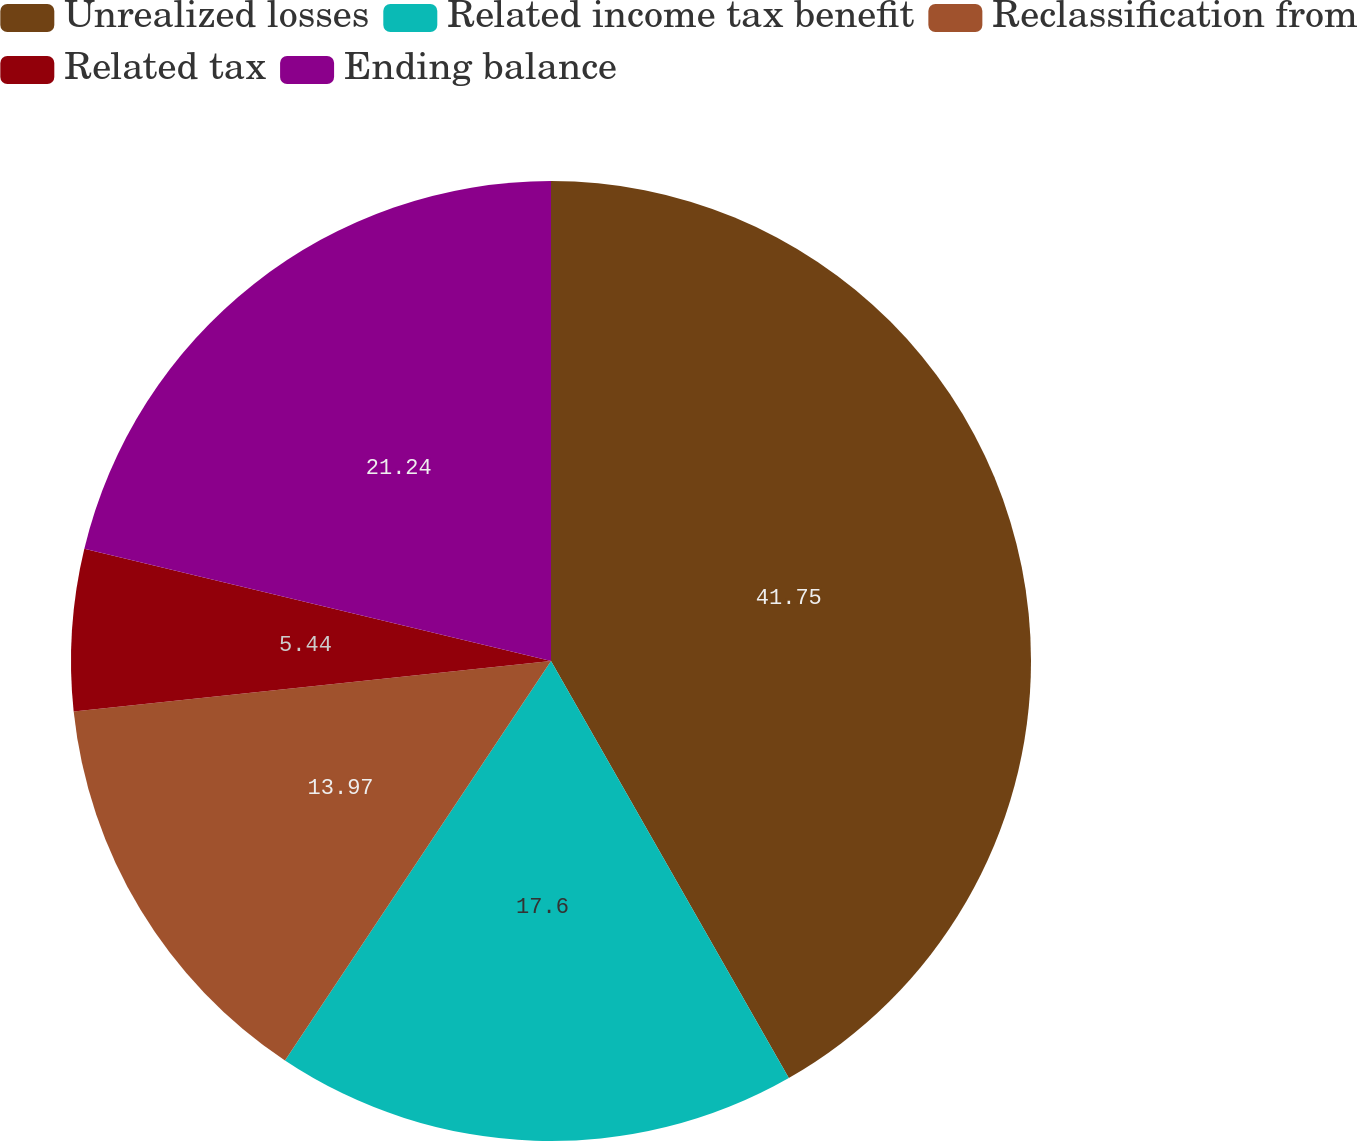Convert chart. <chart><loc_0><loc_0><loc_500><loc_500><pie_chart><fcel>Unrealized losses<fcel>Related income tax benefit<fcel>Reclassification from<fcel>Related tax<fcel>Ending balance<nl><fcel>41.75%<fcel>17.6%<fcel>13.97%<fcel>5.44%<fcel>21.24%<nl></chart> 